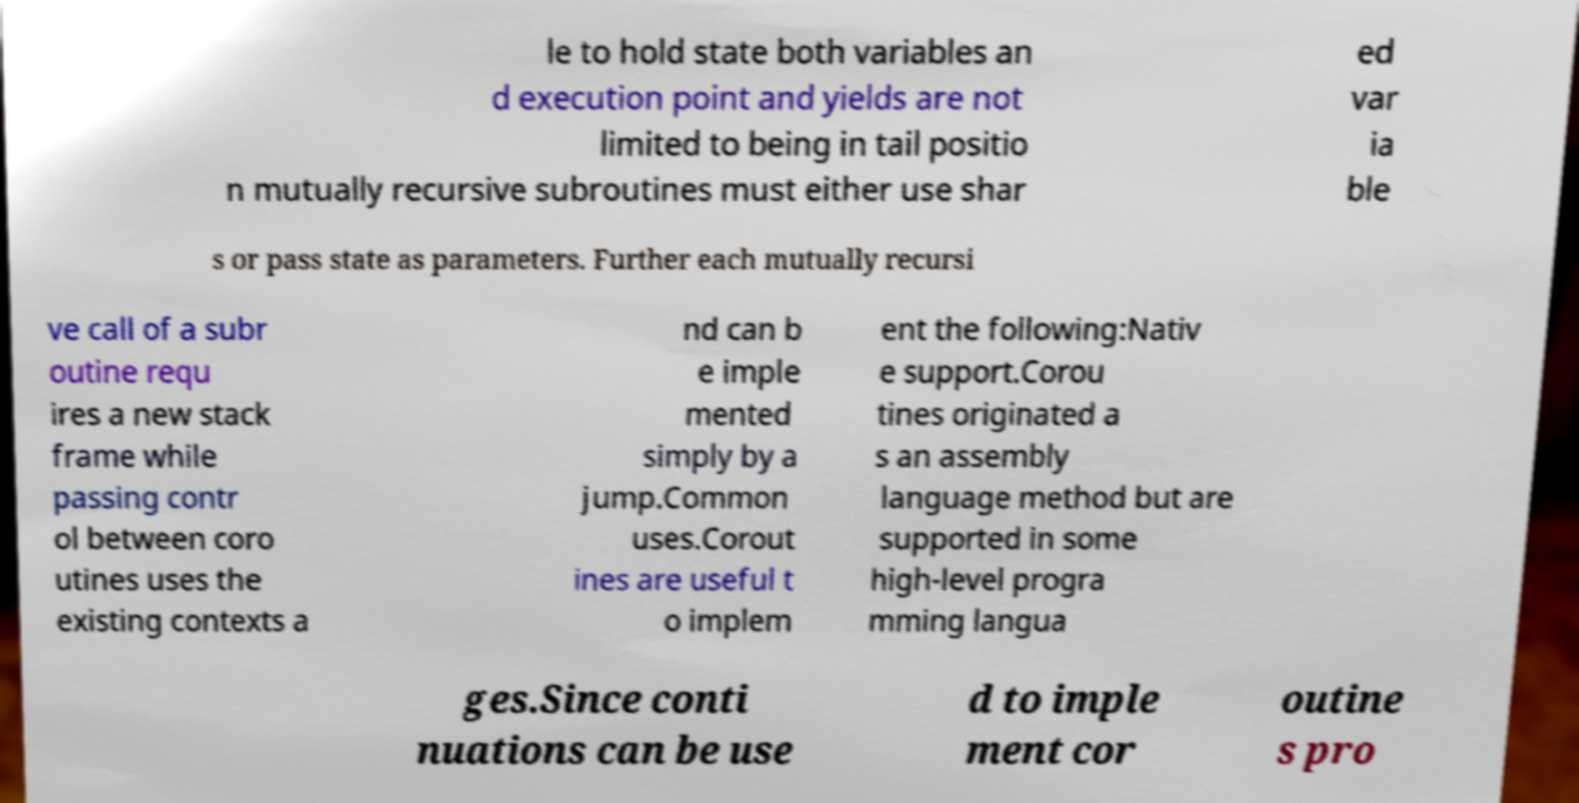Please read and relay the text visible in this image. What does it say? le to hold state both variables an d execution point and yields are not limited to being in tail positio n mutually recursive subroutines must either use shar ed var ia ble s or pass state as parameters. Further each mutually recursi ve call of a subr outine requ ires a new stack frame while passing contr ol between coro utines uses the existing contexts a nd can b e imple mented simply by a jump.Common uses.Corout ines are useful t o implem ent the following:Nativ e support.Corou tines originated a s an assembly language method but are supported in some high-level progra mming langua ges.Since conti nuations can be use d to imple ment cor outine s pro 